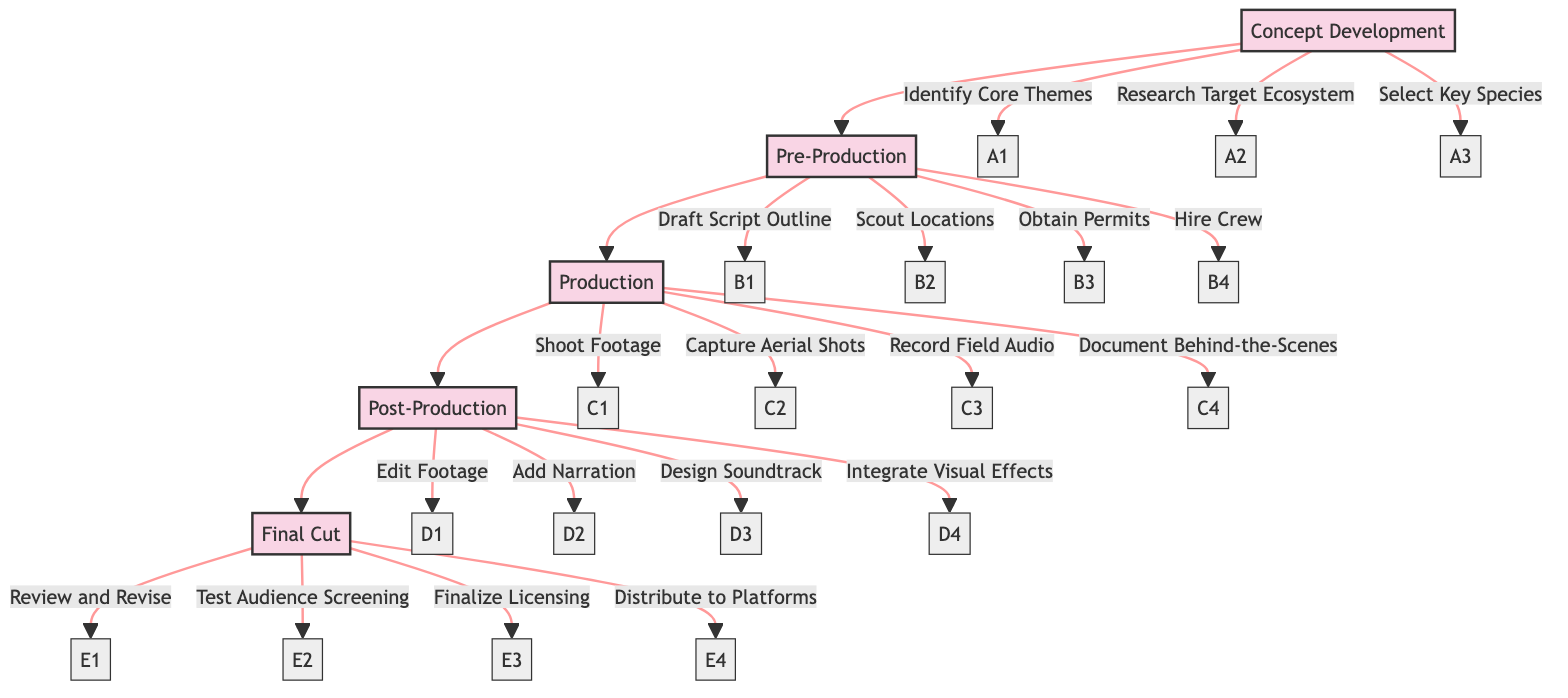What is the first stage of creating a wildlife documentary? The diagram shows "Concept Development" at the top, indicating that it is the initial stage of the process.
Answer: Concept Development How many elements are listed under the Production stage? The Production stage has four elements: "Shoot Footage," "Capture Aerial Shots," "Record Field Audio," and "Document Behind-the-Scenes." Counting these gives a total of four elements.
Answer: 4 What follows the Pre-Production stage? Directly after the Pre-Production stage in the flowchart is the Production stage, indicating that it comes next in the sequence.
Answer: Production Which element is listed under the Post-Production stage that relates to audio? Under the Post-Production stage, the element "Add Narration" relates to audio, indicating that narration is a part of this stage.
Answer: Add Narration What is the last step before the distribution of the documentary? The diagram indicates that "Finalize Licensing" is the second-to-last element in the Final Cut stage, occurring just before distribution.
Answer: Finalize Licensing What is the fourth element in the Pre-Production stage? In the Pre-Production stage, counting the elements reveals that "Hire Crew" is the fourth element listed.
Answer: Hire Crew How many stages are there in total? The diagram includes five distinct stages: Concept Development, Pre-Production, Production, Post-Production, and Final Cut. Thus, the total is five stages.
Answer: 5 Which stage includes location scouting? The element "Scout Locations" is listed under the Pre-Production stage, indicating that this is the stage where location scouting occurs.
Answer: Pre-Production What is the third element listed in the Production stage? Looking at the Production stage, the third element is "Record Field Audio," completing the list of activities during this stage.
Answer: Record Field Audio 